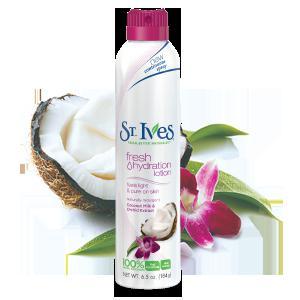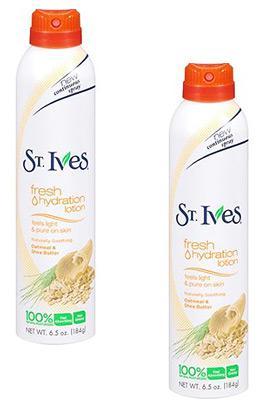The first image is the image on the left, the second image is the image on the right. For the images displayed, is the sentence "there are 7 beauty products in the image pair" factually correct? Answer yes or no. No. The first image is the image on the left, the second image is the image on the right. For the images displayed, is the sentence "The image on the left has one bottle of St. Ives Fresh Hydration Lotion in front of objects that match the objects on the bottle." factually correct? Answer yes or no. Yes. 